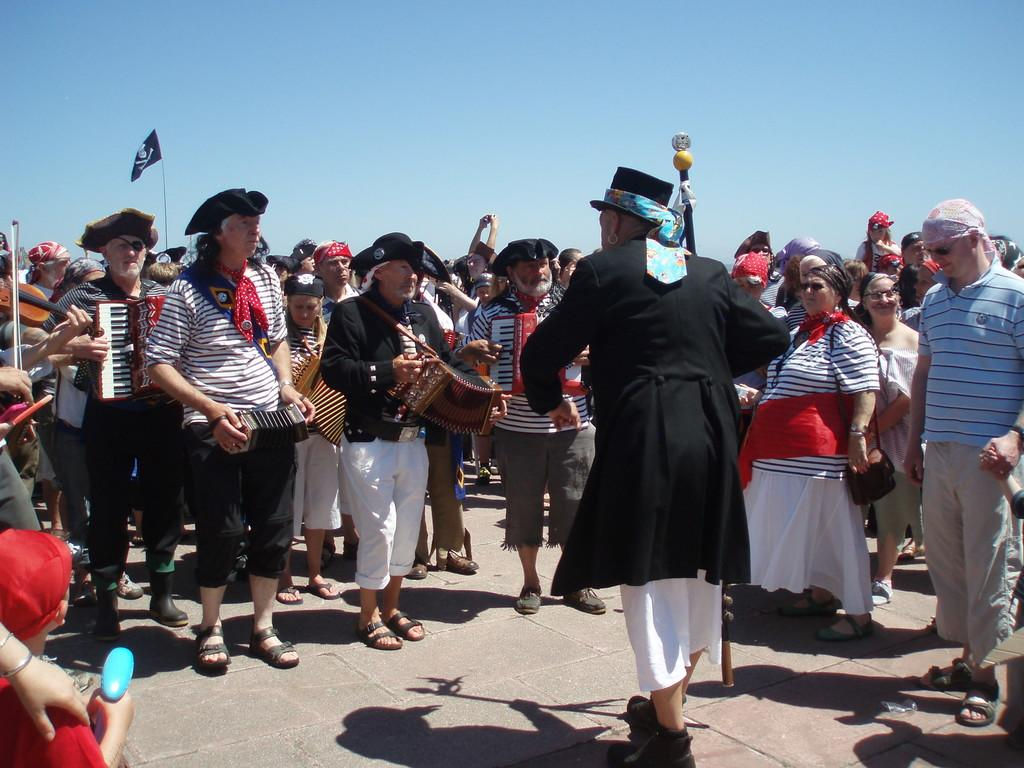What are the people in the image doing? There is a group of people performing musical instruments. Are there any spectators in the image? Yes, there are people watching the performance standing. What type of creature can be seen bursting through the hose in the image? There is no creature or hose present in the image; it features a group of people performing musical instruments and spectators watching the performance. 